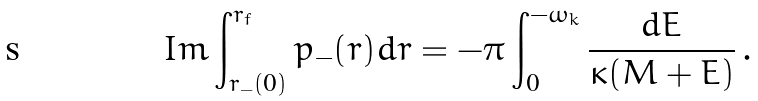Convert formula to latex. <formula><loc_0><loc_0><loc_500><loc_500>I m \int _ { r _ { - } ( 0 ) } ^ { r _ { f } } p _ { - } ( r ) d r = - \pi \int _ { 0 } ^ { - \omega _ { k } } \frac { d E } { \kappa ( M + E ) } \, .</formula> 